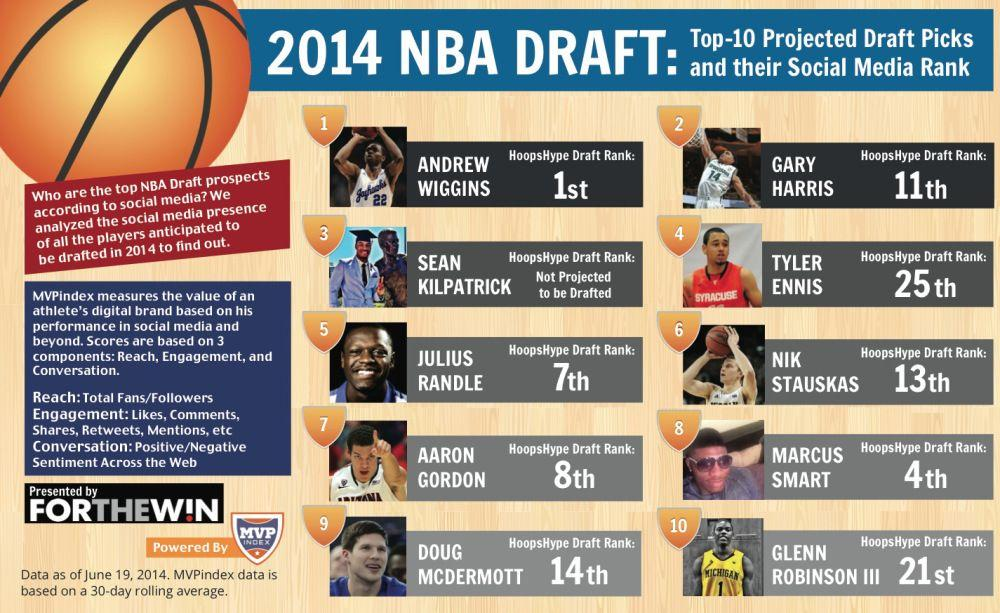Draw attention to some important aspects in this diagram. Of the players, how many have a rank that falls between 20 and 26, inclusive? This infographic features 10 players. Out of the players, how many have a rank that falls between 2 and 10, inclusive? 